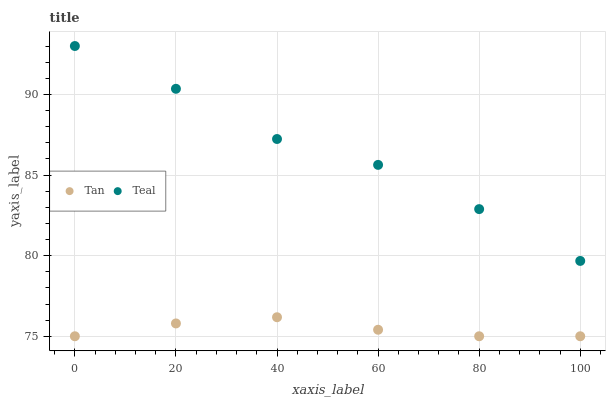Does Tan have the minimum area under the curve?
Answer yes or no. Yes. Does Teal have the maximum area under the curve?
Answer yes or no. Yes. Does Teal have the minimum area under the curve?
Answer yes or no. No. Is Tan the smoothest?
Answer yes or no. Yes. Is Teal the roughest?
Answer yes or no. Yes. Is Teal the smoothest?
Answer yes or no. No. Does Tan have the lowest value?
Answer yes or no. Yes. Does Teal have the lowest value?
Answer yes or no. No. Does Teal have the highest value?
Answer yes or no. Yes. Is Tan less than Teal?
Answer yes or no. Yes. Is Teal greater than Tan?
Answer yes or no. Yes. Does Tan intersect Teal?
Answer yes or no. No. 